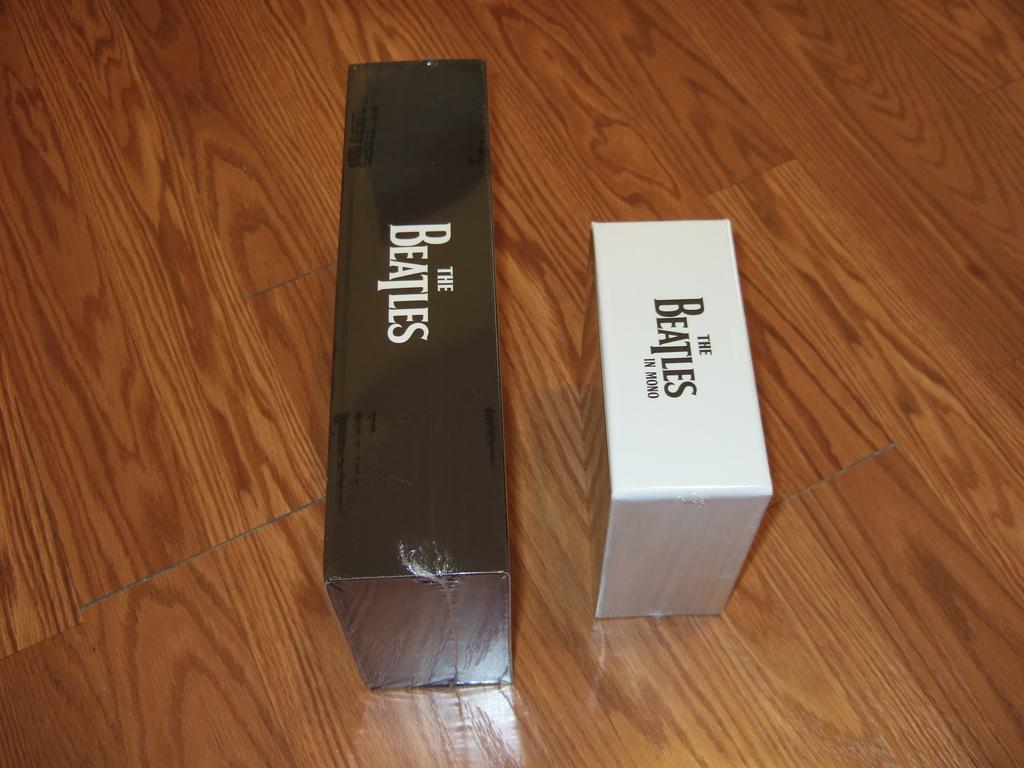<image>
Offer a succinct explanation of the picture presented. Two boxes that have The Beatles printed on them are lying on a wood floor. 